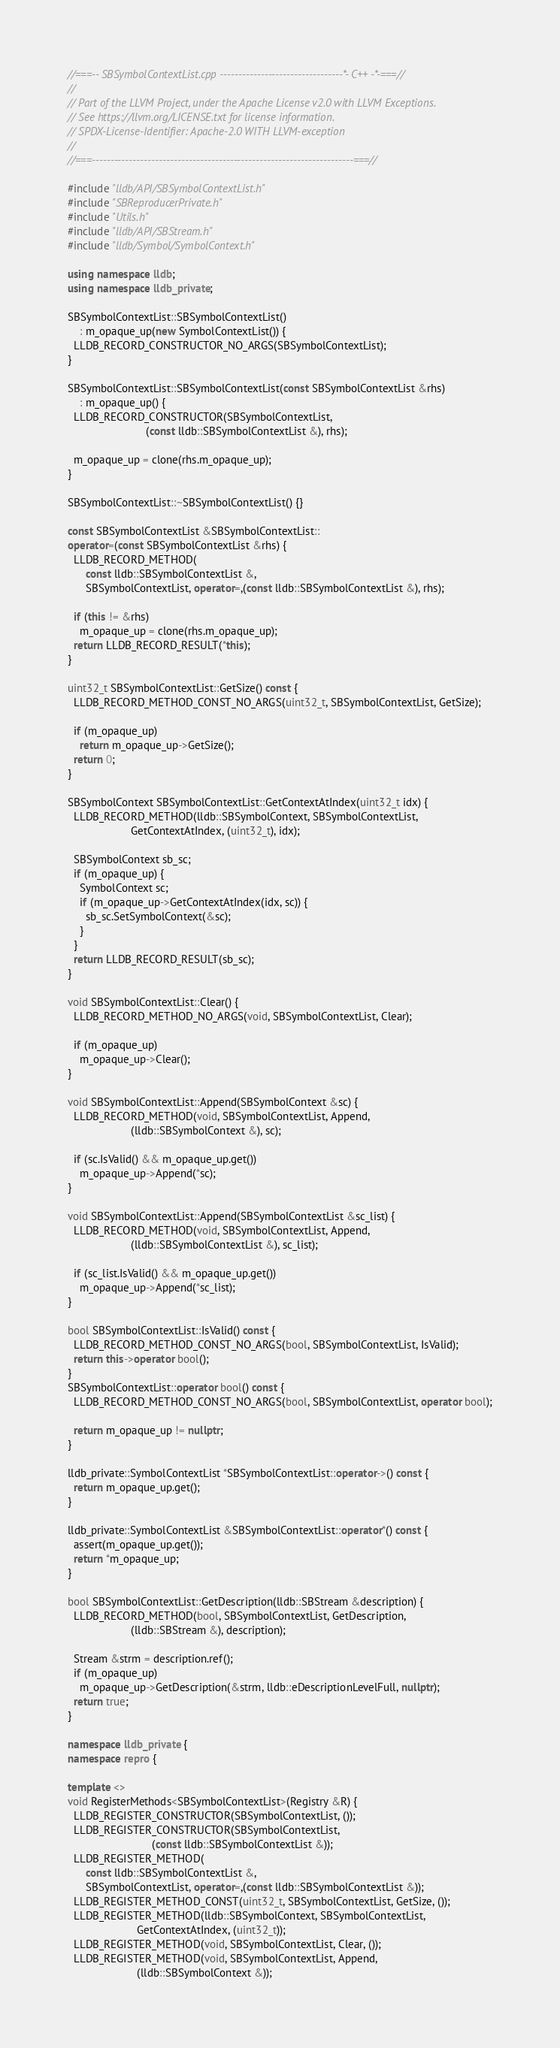<code> <loc_0><loc_0><loc_500><loc_500><_C++_>//===-- SBSymbolContextList.cpp ---------------------------------*- C++ -*-===//
//
// Part of the LLVM Project, under the Apache License v2.0 with LLVM Exceptions.
// See https://llvm.org/LICENSE.txt for license information.
// SPDX-License-Identifier: Apache-2.0 WITH LLVM-exception
//
//===----------------------------------------------------------------------===//

#include "lldb/API/SBSymbolContextList.h"
#include "SBReproducerPrivate.h"
#include "Utils.h"
#include "lldb/API/SBStream.h"
#include "lldb/Symbol/SymbolContext.h"

using namespace lldb;
using namespace lldb_private;

SBSymbolContextList::SBSymbolContextList()
    : m_opaque_up(new SymbolContextList()) {
  LLDB_RECORD_CONSTRUCTOR_NO_ARGS(SBSymbolContextList);
}

SBSymbolContextList::SBSymbolContextList(const SBSymbolContextList &rhs)
    : m_opaque_up() {
  LLDB_RECORD_CONSTRUCTOR(SBSymbolContextList,
                          (const lldb::SBSymbolContextList &), rhs);

  m_opaque_up = clone(rhs.m_opaque_up);
}

SBSymbolContextList::~SBSymbolContextList() {}

const SBSymbolContextList &SBSymbolContextList::
operator=(const SBSymbolContextList &rhs) {
  LLDB_RECORD_METHOD(
      const lldb::SBSymbolContextList &,
      SBSymbolContextList, operator=,(const lldb::SBSymbolContextList &), rhs);

  if (this != &rhs)
    m_opaque_up = clone(rhs.m_opaque_up);
  return LLDB_RECORD_RESULT(*this);
}

uint32_t SBSymbolContextList::GetSize() const {
  LLDB_RECORD_METHOD_CONST_NO_ARGS(uint32_t, SBSymbolContextList, GetSize);

  if (m_opaque_up)
    return m_opaque_up->GetSize();
  return 0;
}

SBSymbolContext SBSymbolContextList::GetContextAtIndex(uint32_t idx) {
  LLDB_RECORD_METHOD(lldb::SBSymbolContext, SBSymbolContextList,
                     GetContextAtIndex, (uint32_t), idx);

  SBSymbolContext sb_sc;
  if (m_opaque_up) {
    SymbolContext sc;
    if (m_opaque_up->GetContextAtIndex(idx, sc)) {
      sb_sc.SetSymbolContext(&sc);
    }
  }
  return LLDB_RECORD_RESULT(sb_sc);
}

void SBSymbolContextList::Clear() {
  LLDB_RECORD_METHOD_NO_ARGS(void, SBSymbolContextList, Clear);

  if (m_opaque_up)
    m_opaque_up->Clear();
}

void SBSymbolContextList::Append(SBSymbolContext &sc) {
  LLDB_RECORD_METHOD(void, SBSymbolContextList, Append,
                     (lldb::SBSymbolContext &), sc);

  if (sc.IsValid() && m_opaque_up.get())
    m_opaque_up->Append(*sc);
}

void SBSymbolContextList::Append(SBSymbolContextList &sc_list) {
  LLDB_RECORD_METHOD(void, SBSymbolContextList, Append,
                     (lldb::SBSymbolContextList &), sc_list);

  if (sc_list.IsValid() && m_opaque_up.get())
    m_opaque_up->Append(*sc_list);
}

bool SBSymbolContextList::IsValid() const {
  LLDB_RECORD_METHOD_CONST_NO_ARGS(bool, SBSymbolContextList, IsValid);
  return this->operator bool();
}
SBSymbolContextList::operator bool() const {
  LLDB_RECORD_METHOD_CONST_NO_ARGS(bool, SBSymbolContextList, operator bool);

  return m_opaque_up != nullptr;
}

lldb_private::SymbolContextList *SBSymbolContextList::operator->() const {
  return m_opaque_up.get();
}

lldb_private::SymbolContextList &SBSymbolContextList::operator*() const {
  assert(m_opaque_up.get());
  return *m_opaque_up;
}

bool SBSymbolContextList::GetDescription(lldb::SBStream &description) {
  LLDB_RECORD_METHOD(bool, SBSymbolContextList, GetDescription,
                     (lldb::SBStream &), description);

  Stream &strm = description.ref();
  if (m_opaque_up)
    m_opaque_up->GetDescription(&strm, lldb::eDescriptionLevelFull, nullptr);
  return true;
}

namespace lldb_private {
namespace repro {

template <>
void RegisterMethods<SBSymbolContextList>(Registry &R) {
  LLDB_REGISTER_CONSTRUCTOR(SBSymbolContextList, ());
  LLDB_REGISTER_CONSTRUCTOR(SBSymbolContextList,
                            (const lldb::SBSymbolContextList &));
  LLDB_REGISTER_METHOD(
      const lldb::SBSymbolContextList &,
      SBSymbolContextList, operator=,(const lldb::SBSymbolContextList &));
  LLDB_REGISTER_METHOD_CONST(uint32_t, SBSymbolContextList, GetSize, ());
  LLDB_REGISTER_METHOD(lldb::SBSymbolContext, SBSymbolContextList,
                       GetContextAtIndex, (uint32_t));
  LLDB_REGISTER_METHOD(void, SBSymbolContextList, Clear, ());
  LLDB_REGISTER_METHOD(void, SBSymbolContextList, Append,
                       (lldb::SBSymbolContext &));</code> 